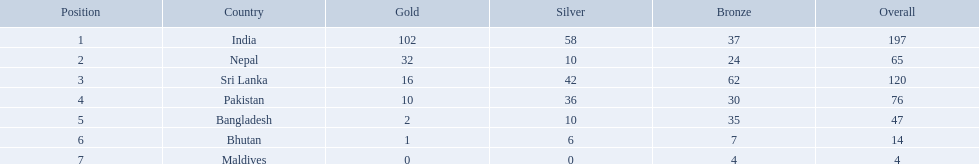What were the total amount won of medals by nations in the 1999 south asian games? 197, 65, 120, 76, 47, 14, 4. Which amount was the lowest? 4. Which nation had this amount? Maldives. What nations took part in 1999 south asian games? India, Nepal, Sri Lanka, Pakistan, Bangladesh, Bhutan, Maldives. Of those who earned gold medals? India, Nepal, Sri Lanka, Pakistan, Bangladesh, Bhutan. Which nation didn't earn any gold medals? Maldives. What are the nations? India, Nepal, Sri Lanka, Pakistan, Bangladesh, Bhutan, Maldives. Of these, which one has earned the least amount of gold medals? Maldives. How many gold medals were won by the teams? 102, 32, 16, 10, 2, 1, 0. What country won no gold medals? Maldives. 